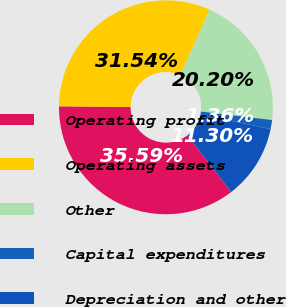Convert chart. <chart><loc_0><loc_0><loc_500><loc_500><pie_chart><fcel>Operating profit<fcel>Operating assets<fcel>Other<fcel>Capital expenditures<fcel>Depreciation and other<nl><fcel>35.59%<fcel>31.54%<fcel>20.2%<fcel>1.36%<fcel>11.3%<nl></chart> 